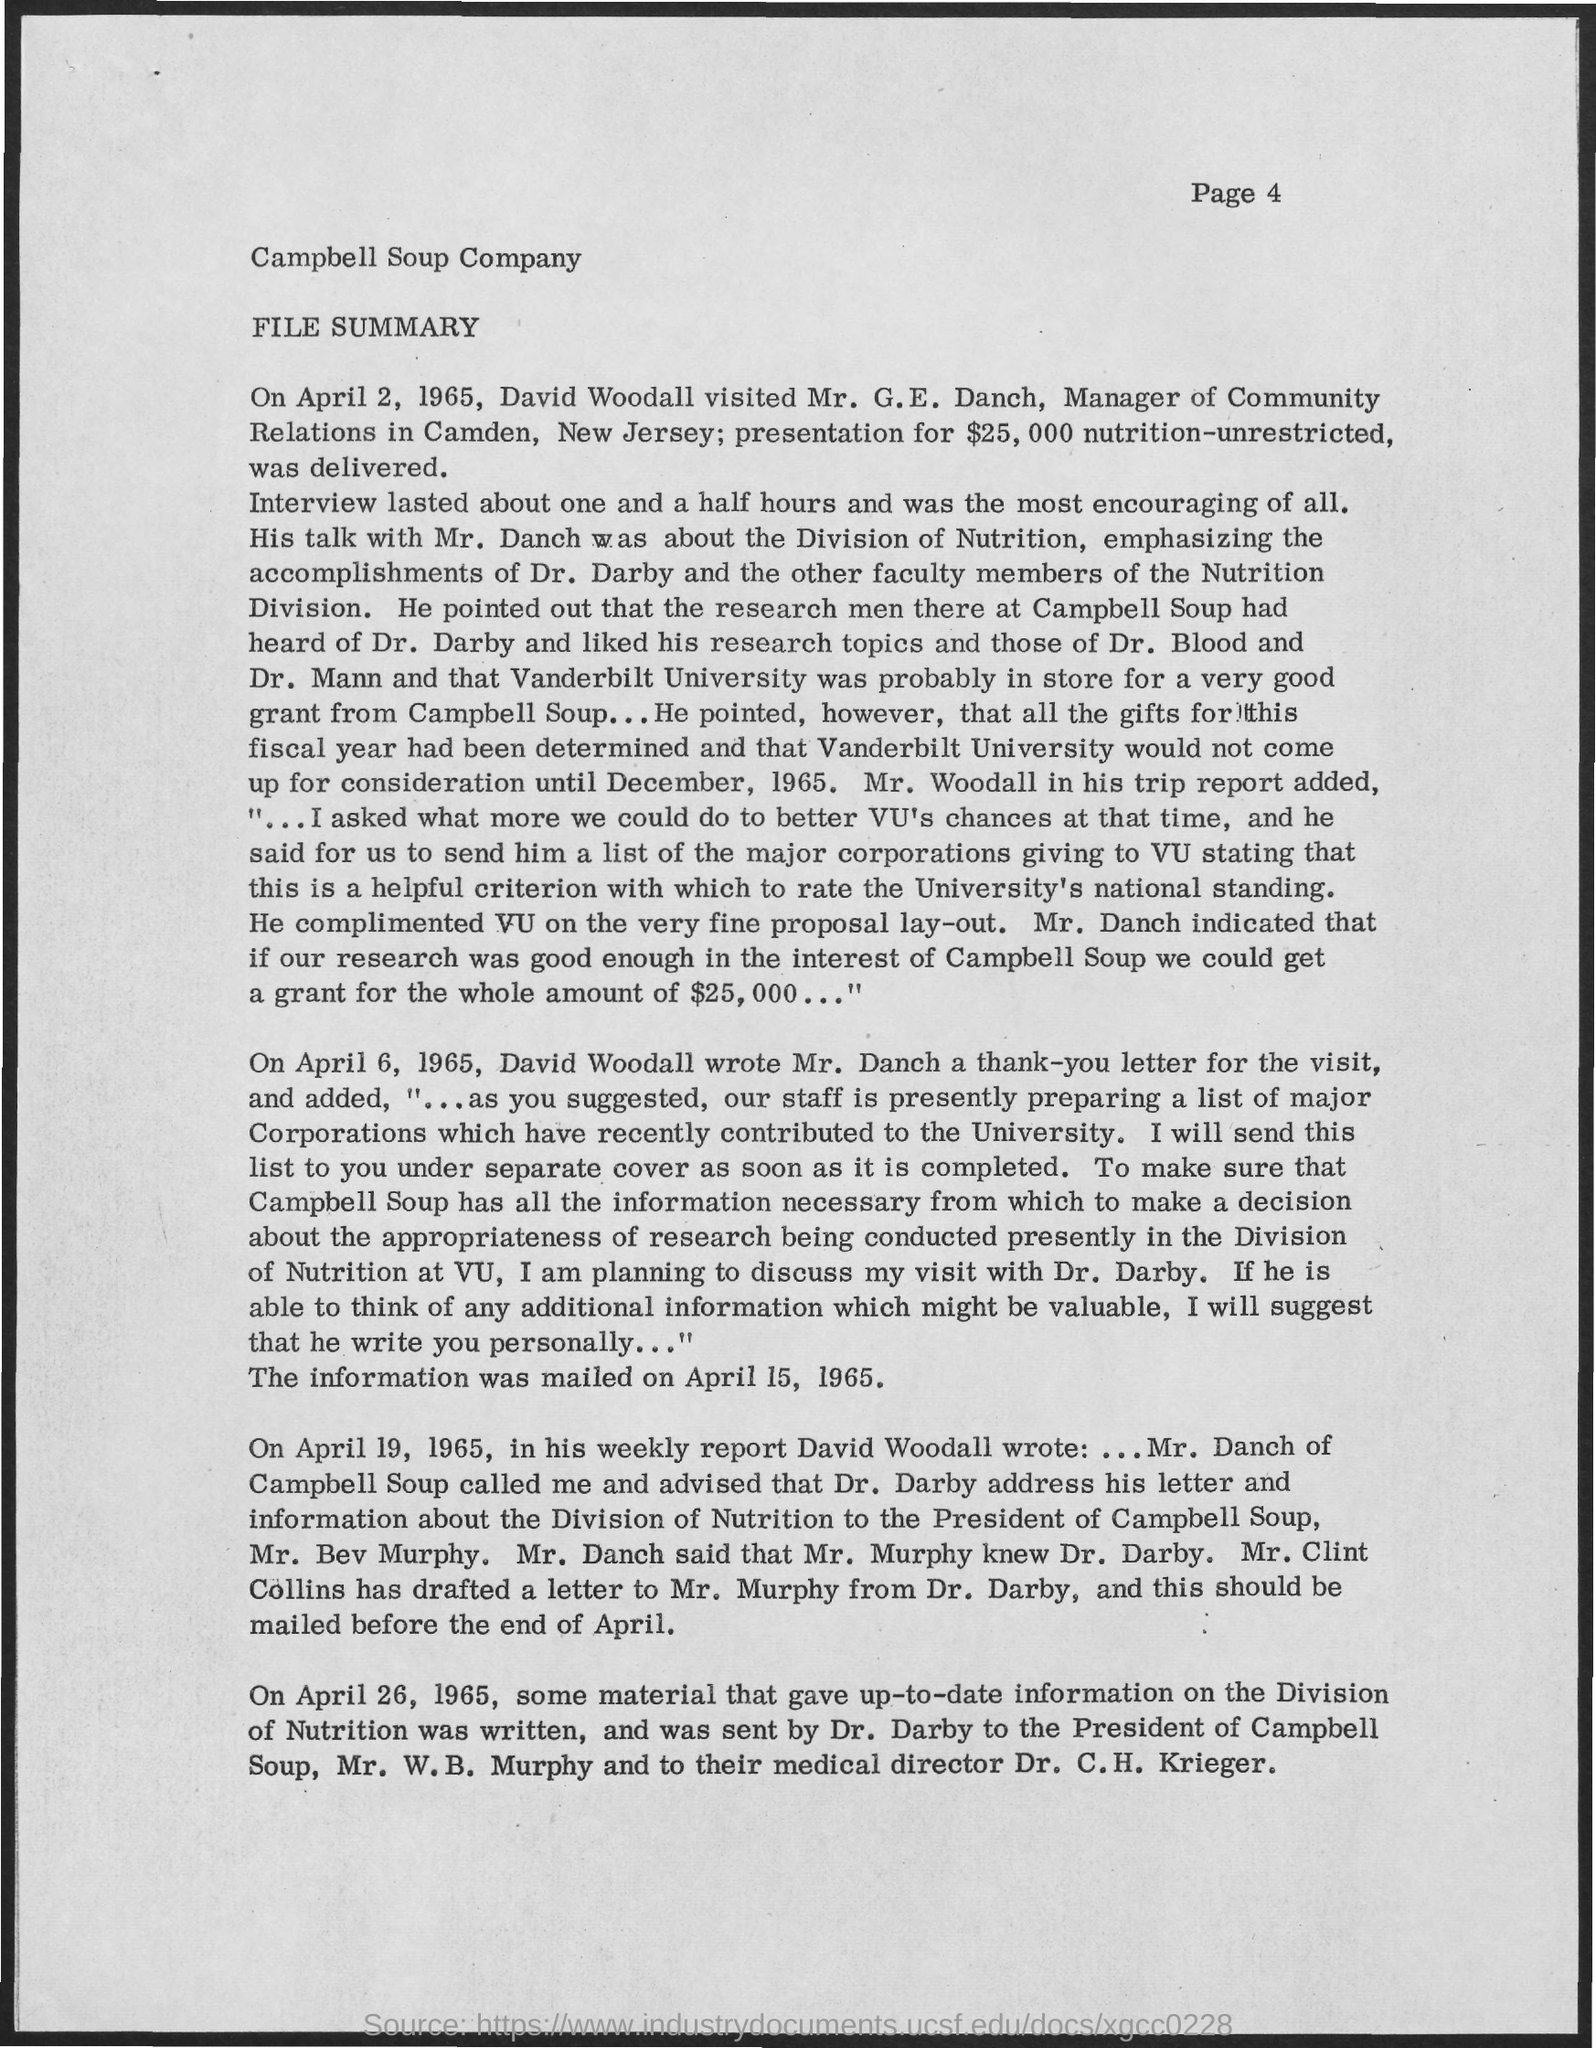Outline some significant characteristics in this image. Campbell Soup Company is a well-known company that produces various food products. 